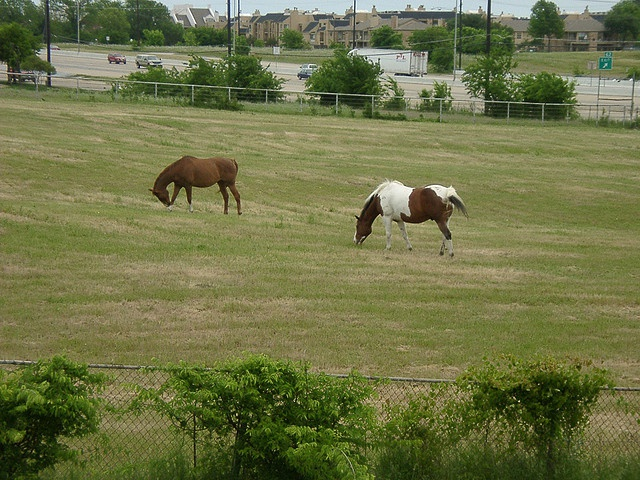Describe the objects in this image and their specific colors. I can see horse in darkgreen, black, maroon, beige, and darkgray tones, horse in darkgreen, maroon, black, and olive tones, truck in darkgreen, darkgray, lightgray, and gray tones, car in darkgreen, darkgray, gray, black, and beige tones, and car in darkgreen, gray, darkgray, and black tones in this image. 